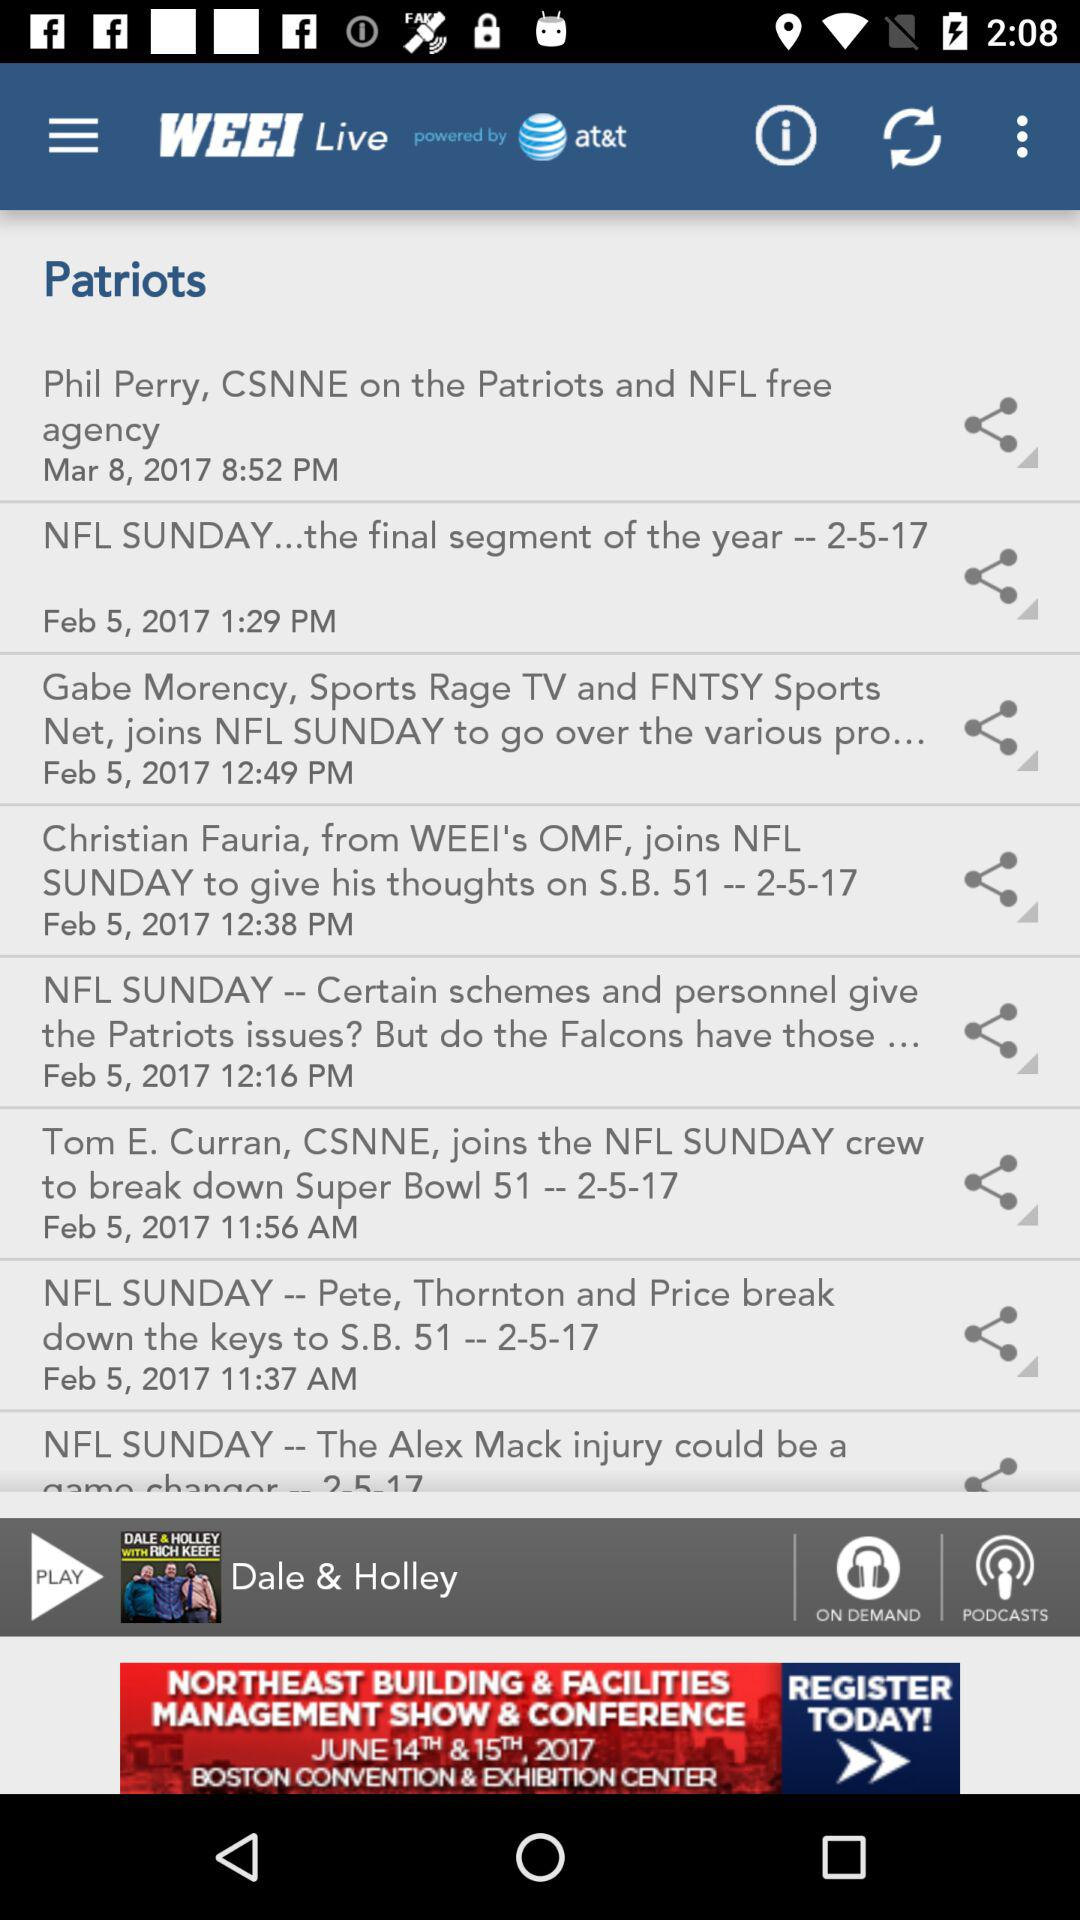On which date is the "NFL Sunday the final segment of the year" updated? The date is February 5, 2017. 